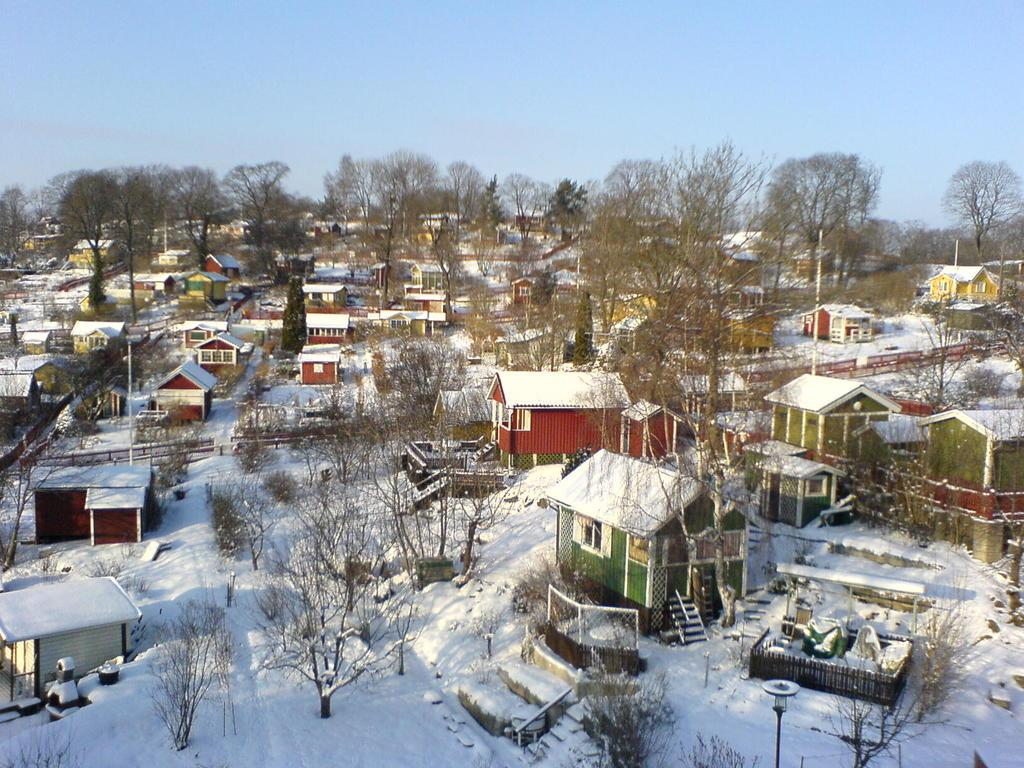What type of structures can be seen on the ground in the image? There are houses on the ground in the image. What is covering the ground in the image? The ground is covered with snow in the image. What type of vegetation is present in the image? There are trees in the image. What type of man-made structures can be seen in the image? Light poles are present in the image. What type of barrier is visible in the image? There is a fence in the image. What is visible above the ground in the image? The sky is visible in the image. What type of insurance policy is being discussed by the pigs in the image? There are no pigs present in the image, and therefore no discussion about insurance policies can be observed. What type of border is visible between the houses and the trees in the image? There is no visible border between the houses and the trees in the image; only a fence is mentioned. 